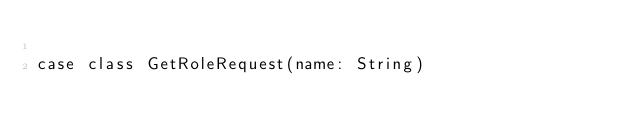Convert code to text. <code><loc_0><loc_0><loc_500><loc_500><_Scala_>
case class GetRoleRequest(name: String)
</code> 